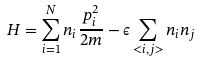Convert formula to latex. <formula><loc_0><loc_0><loc_500><loc_500>H = \sum _ { i = 1 } ^ { N } n _ { i } \frac { p _ { i } ^ { 2 } } { 2 m } - \epsilon \sum _ { < i , j > } n _ { i } n _ { j }</formula> 